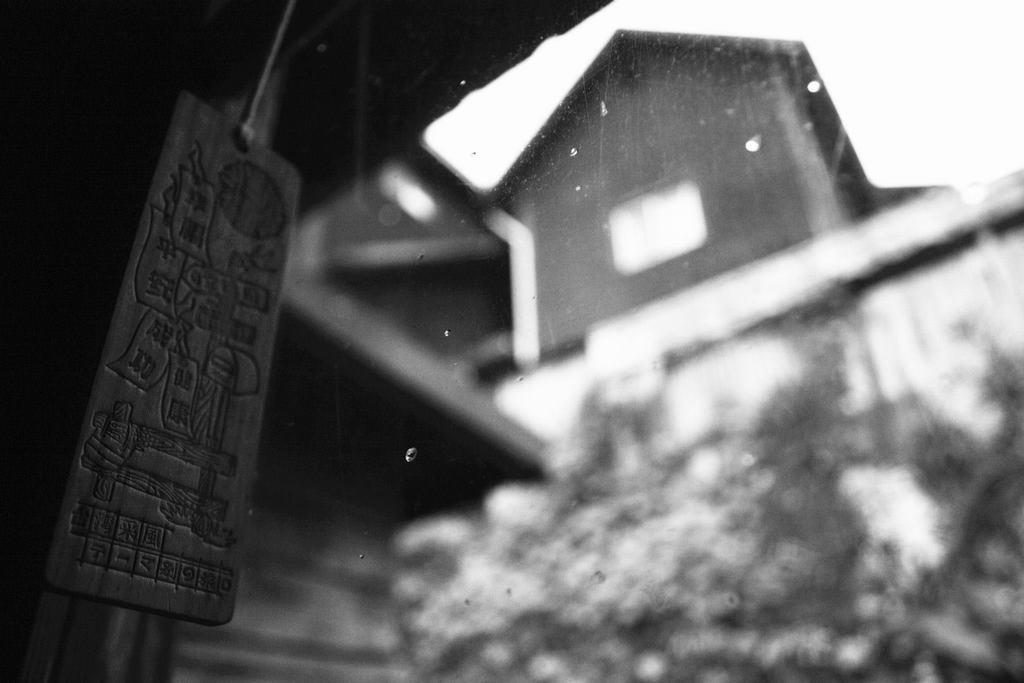Can you describe this image briefly? On the left there is a wooden object hanging. In this picture there is a glass object, outside the glass it is looking like house and trees it is not clear. 